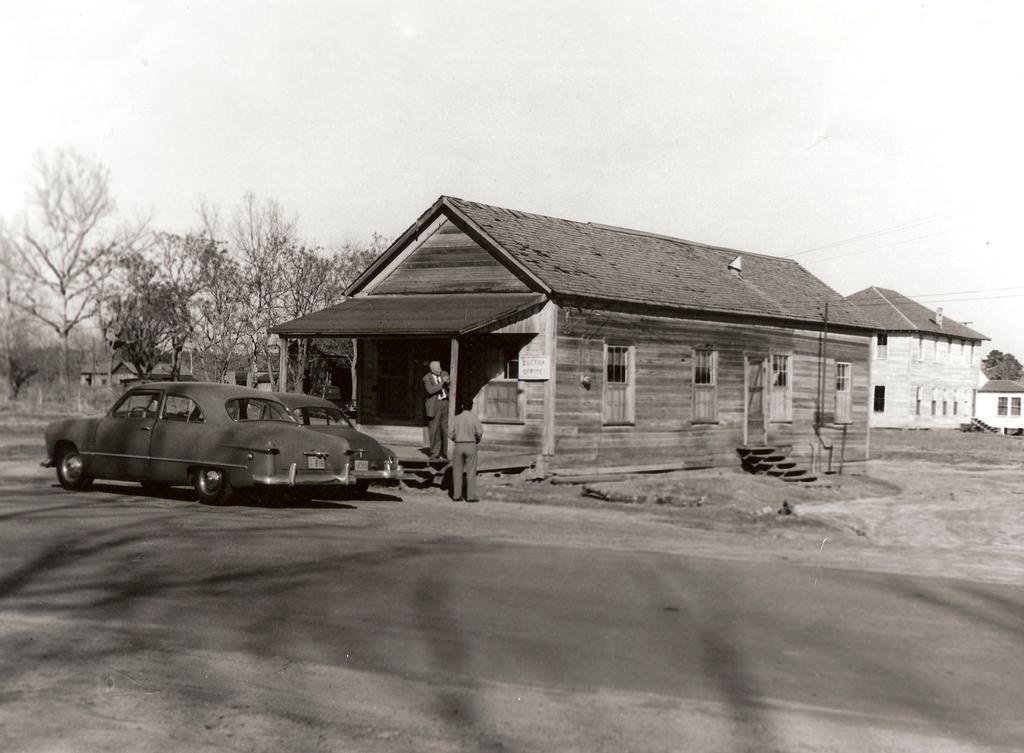How would you summarize this image in a sentence or two? In this image we can see two people, there are some houses, windows, cars on the road, there are some trees, also we can see the sky. 